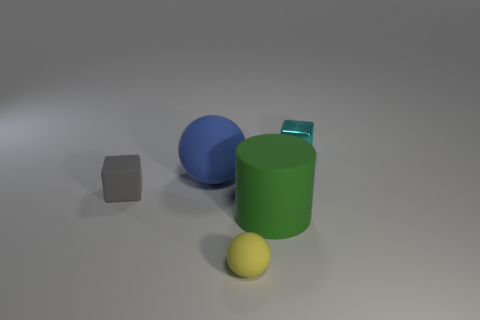Are there any small metallic cylinders that have the same color as the rubber block?
Make the answer very short. No. What is the shape of the tiny yellow thing?
Your response must be concise. Sphere. What is the color of the matte ball that is in front of the rubber thing behind the small rubber block?
Provide a short and direct response. Yellow. There is a thing behind the large blue ball; how big is it?
Your answer should be very brief. Small. Are there any other large spheres that have the same material as the big blue sphere?
Provide a succinct answer. No. What number of other small rubber objects have the same shape as the blue rubber thing?
Offer a very short reply. 1. What shape is the big object behind the gray object behind the thing in front of the green cylinder?
Make the answer very short. Sphere. What is the material of the thing that is behind the tiny rubber block and on the right side of the small matte ball?
Your answer should be very brief. Metal. There is a metallic object that is behind the green cylinder; is it the same size as the tiny yellow matte object?
Provide a short and direct response. Yes. Is there any other thing that is the same size as the cyan shiny block?
Your response must be concise. Yes. 